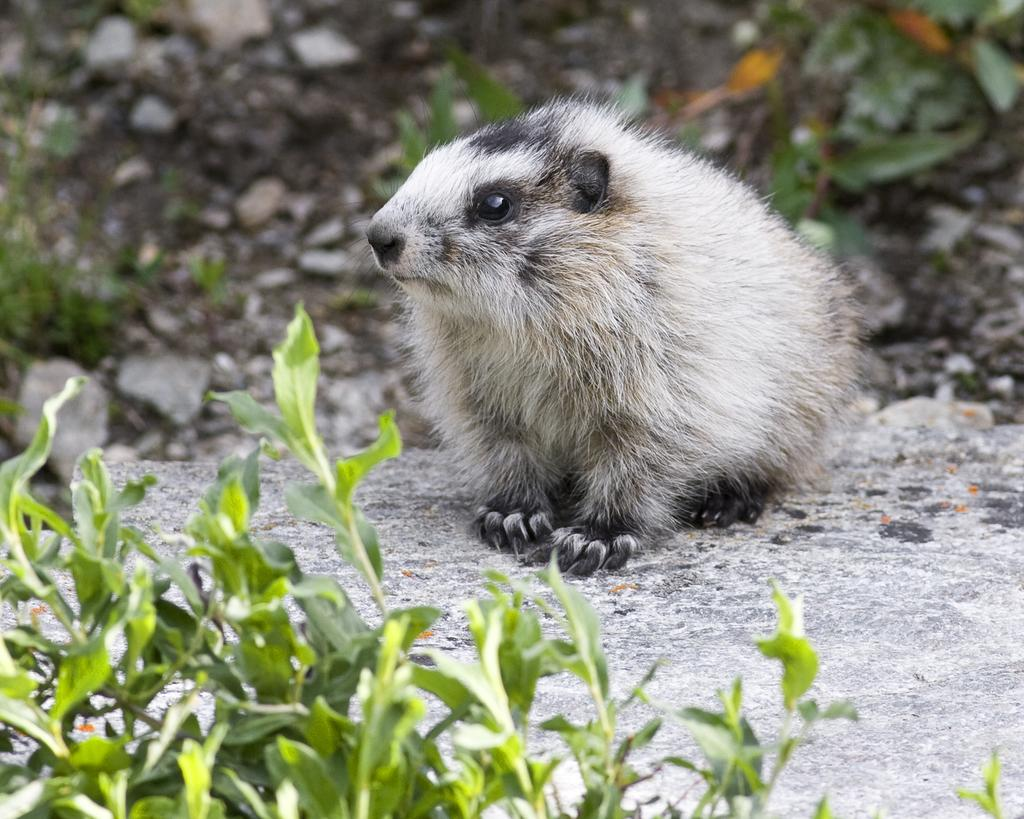What type of animal can be seen on the ground in the image? The specific type of animal cannot be determined from the provided facts. What else is present in the image besides the animal? There are leaves in the image. How would you describe the background of the image? The background of the image is blurry. What is the income of the animal in the image? There is no information about the animal's income in the image. On which side of the image is the flag located? There is no flag present in the image. 